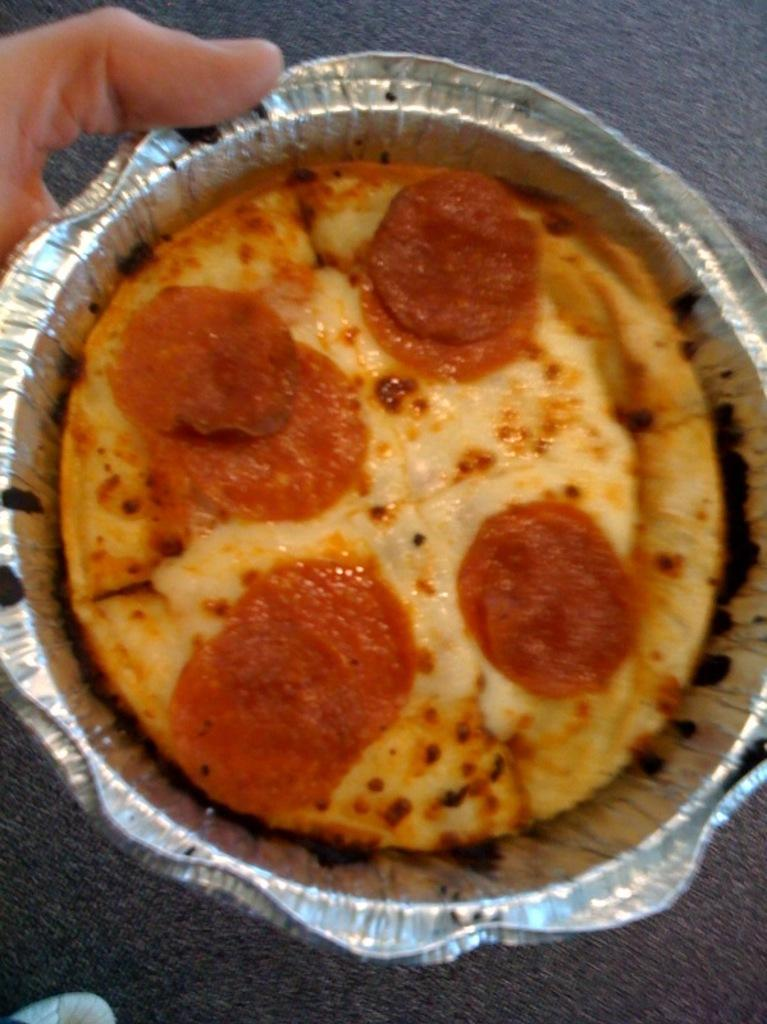What type of bowl is in the image? There is a foil bowl in the image. What is inside the bowl? The bowl contains Baked mac. What topping is added to the Baked mac? Pepperoni is sprinkled on the Baked mac. How does the feeling of the pickle contribute to the taste of the Baked mac in the image? There is no pickle present in the image, so its feeling and contribution to the taste cannot be determined. 